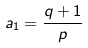<formula> <loc_0><loc_0><loc_500><loc_500>a _ { 1 } = \frac { q + 1 } { p }</formula> 